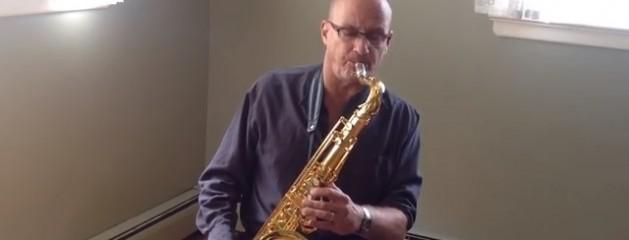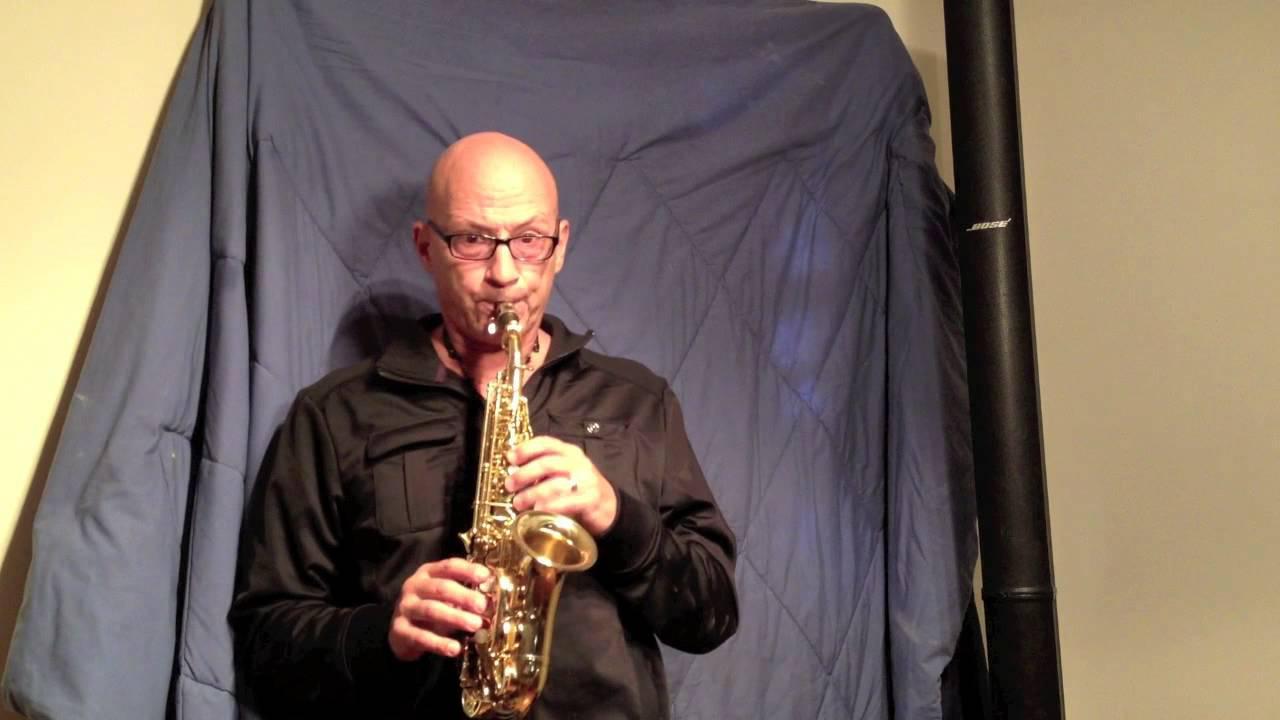The first image is the image on the left, the second image is the image on the right. Examine the images to the left and right. Is the description "Each image shows a man with the mouthpiece of a brass-colored saxophone in his mouth." accurate? Answer yes or no. Yes. The first image is the image on the left, the second image is the image on the right. Assess this claim about the two images: "The man is playing the alto sax and has it to his mouth in both of the images.". Correct or not? Answer yes or no. Yes. 